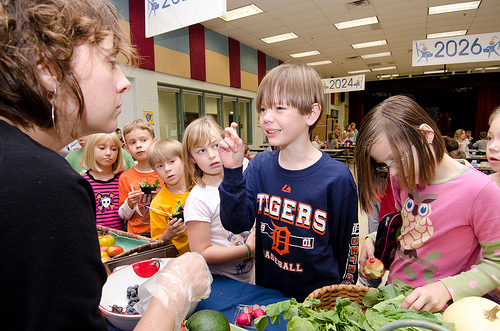<image>
Can you confirm if the mascot is on the boy? Yes. Looking at the image, I can see the mascot is positioned on top of the boy, with the boy providing support. Is there a girl to the left of the boy? Yes. From this viewpoint, the girl is positioned to the left side relative to the boy. Is the boy behind the woman? No. The boy is not behind the woman. From this viewpoint, the boy appears to be positioned elsewhere in the scene. 